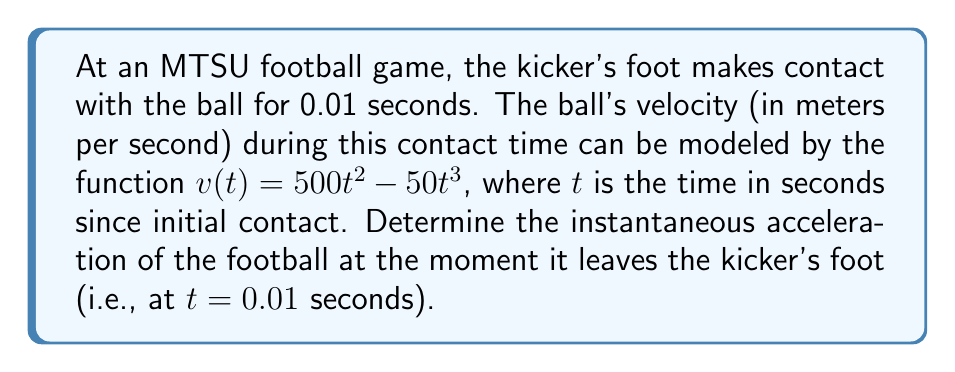Help me with this question. To find the instantaneous acceleration at $t = 0.01$ seconds, we need to follow these steps:

1) The acceleration is the derivative of velocity with respect to time. So, we first need to find $\frac{dv}{dt}$.

2) Given velocity function: $v(t) = 500t^2 - 50t^3$

3) Taking the derivative:
   $$\frac{dv}{dt} = 1000t - 150t^2$$

4) This gives us the acceleration function $a(t)$.

5) To find the instantaneous acceleration at $t = 0.01$, we substitute this value into $a(t)$:

   $a(0.01) = 1000(0.01) - 150(0.01)^2$
   
   $= 10 - 150(0.0001)$
   
   $= 10 - 0.015$
   
   $= 9.985$

6) The units for acceleration are meters per second squared (m/s²).

Therefore, the instantaneous acceleration of the football at the moment it leaves the kicker's foot is 9.985 m/s².
Answer: 9.985 m/s² 